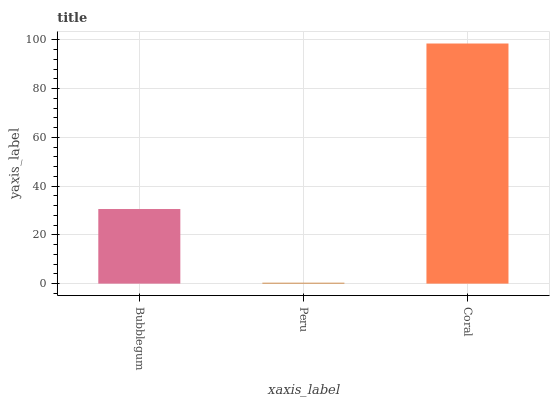Is Peru the minimum?
Answer yes or no. Yes. Is Coral the maximum?
Answer yes or no. Yes. Is Coral the minimum?
Answer yes or no. No. Is Peru the maximum?
Answer yes or no. No. Is Coral greater than Peru?
Answer yes or no. Yes. Is Peru less than Coral?
Answer yes or no. Yes. Is Peru greater than Coral?
Answer yes or no. No. Is Coral less than Peru?
Answer yes or no. No. Is Bubblegum the high median?
Answer yes or no. Yes. Is Bubblegum the low median?
Answer yes or no. Yes. Is Peru the high median?
Answer yes or no. No. Is Coral the low median?
Answer yes or no. No. 